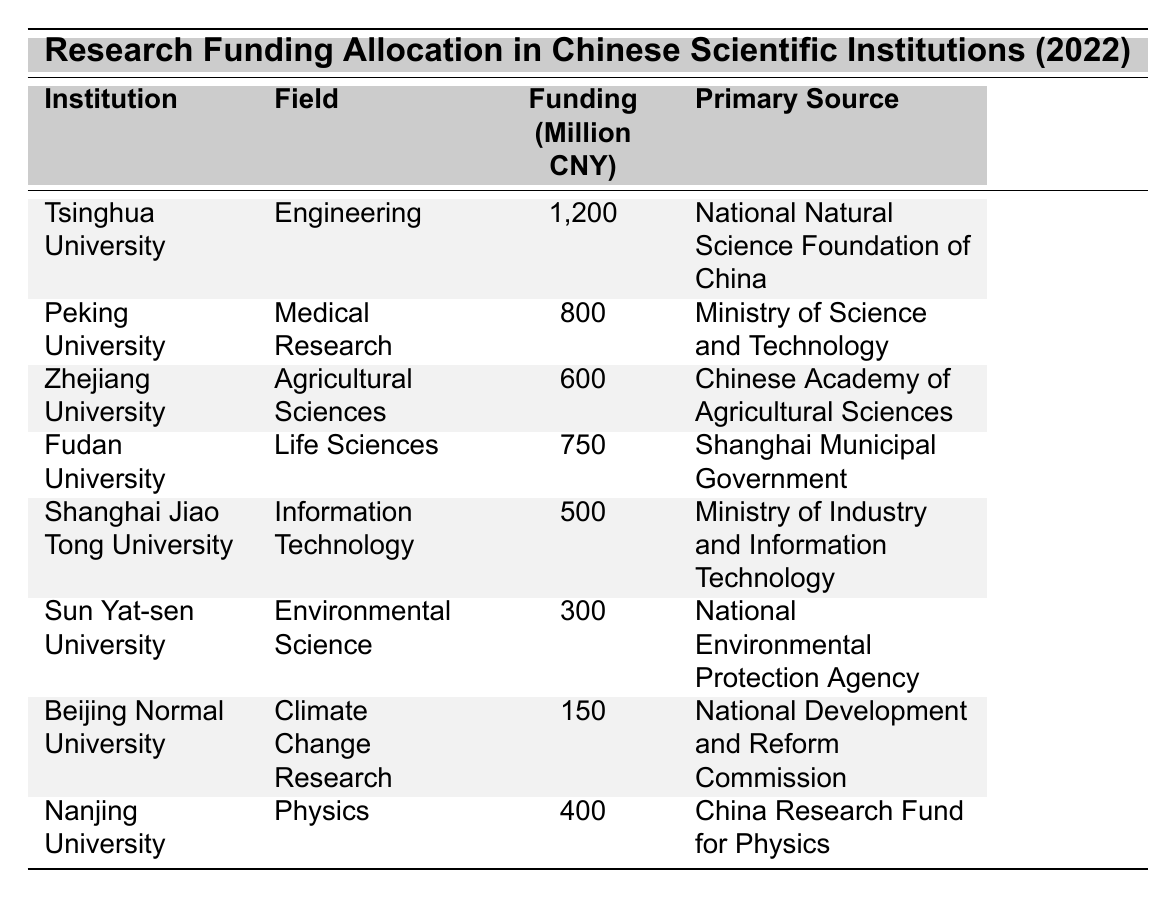What institution received the highest funding amount? By reviewing the table, Tsinghua University is listed with the highest funding amount of 1200 million CNY.
Answer: Tsinghua University How much funding did Fudan University receive? Fudan University is shown in the table with a funding amount of 750 million CNY.
Answer: 750 million CNY Which field received funding from the Ministry of Science and Technology? Upon examining the table, Peking University received funding in the field of Medical Research from the Ministry of Science and Technology.
Answer: Medical Research What is the total funding allocated to the Agricultural Sciences field? The table indicates that Zhejiang University received 600 million CNY for Agricultural Sciences. There are no other entries for this field, so the total is 600 million CNY.
Answer: 600 million CNY Is there any institution that received less than 200 million CNY? By checking the funding amounts, the lowest amount listed is 150 million CNY for Beijing Normal University, which confirms that there is an institution below 200 million CNY.
Answer: Yes What is the average funding amount across all institutions? First, sum the funding amounts: 1200 + 800 + 600 + 750 + 500 + 300 + 150 + 400 = 3750 million CNY. Then divide by the number of institutions (8): 3750 / 8 = 468.75 million CNY.
Answer: 468.75 million CNY Which institution received funding from the Shanghai Municipal Government? The table shows that Fudan University received funding from the Shanghai Municipal Government.
Answer: Fudan University Compare the funding given to Sun Yat-sen University and Nanjing University. Which one received more? Sun Yat-sen University received 300 million CNY while Nanjing University received 400 million CNY. Since 400 million CNY is greater than 300 million CNY, Nanjing University received more funding.
Answer: Nanjing University How much more funding did Tsinghua University receive compared to Sun Yat-sen University? Tsinghua University received 1200 million CNY, and Sun Yat-sen University received 300 million CNY. The difference is 1200 - 300 = 900 million CNY.
Answer: 900 million CNY What percentage of funding is allocated to Information Technology compared to the total funding? The funding for Information Technology at Shanghai Jiao Tong University is 500 million CNY. The total funding is 3750 million CNY. The percentage is (500 / 3750) * 100 = 13.33%.
Answer: 13.33% 